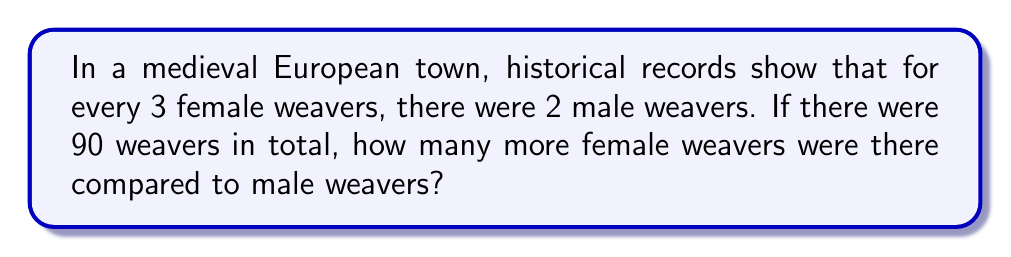Can you answer this question? Let's approach this step-by-step:

1) First, we need to understand the ratio of female to male weavers:
   $\text{Female} : \text{Male} = 3 : 2$

2) This means that out of every 5 weavers (3 + 2), 3 are female and 2 are male.

3) We can set up a proportion to find the number of female weavers:
   $$\frac{3}{5} = \frac{x}{90}$$
   Where $x$ is the number of female weavers.

4) Cross multiply:
   $$3 \cdot 90 = 5x$$
   $$270 = 5x$$

5) Solve for $x$:
   $$x = \frac{270}{5} = 54$$

6) So there are 54 female weavers.

7) To find the number of male weavers, subtract from the total:
   $$90 - 54 = 36$$

8) To find how many more female weavers there are, subtract:
   $$54 - 36 = 18$$

Therefore, there are 18 more female weavers than male weavers.
Answer: 18 more female weavers 